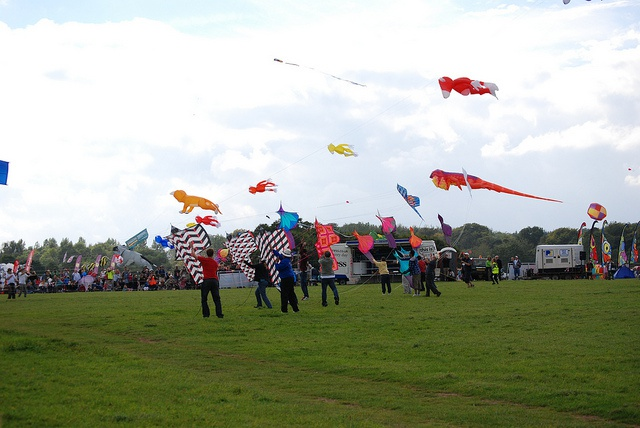Describe the objects in this image and their specific colors. I can see kite in white, black, gray, lightgray, and darkgray tones, people in white, black, gray, darkgreen, and maroon tones, bus in white, black, and gray tones, people in white, black, maroon, darkgreen, and gray tones, and kite in white, darkgray, black, lightgray, and gray tones in this image. 